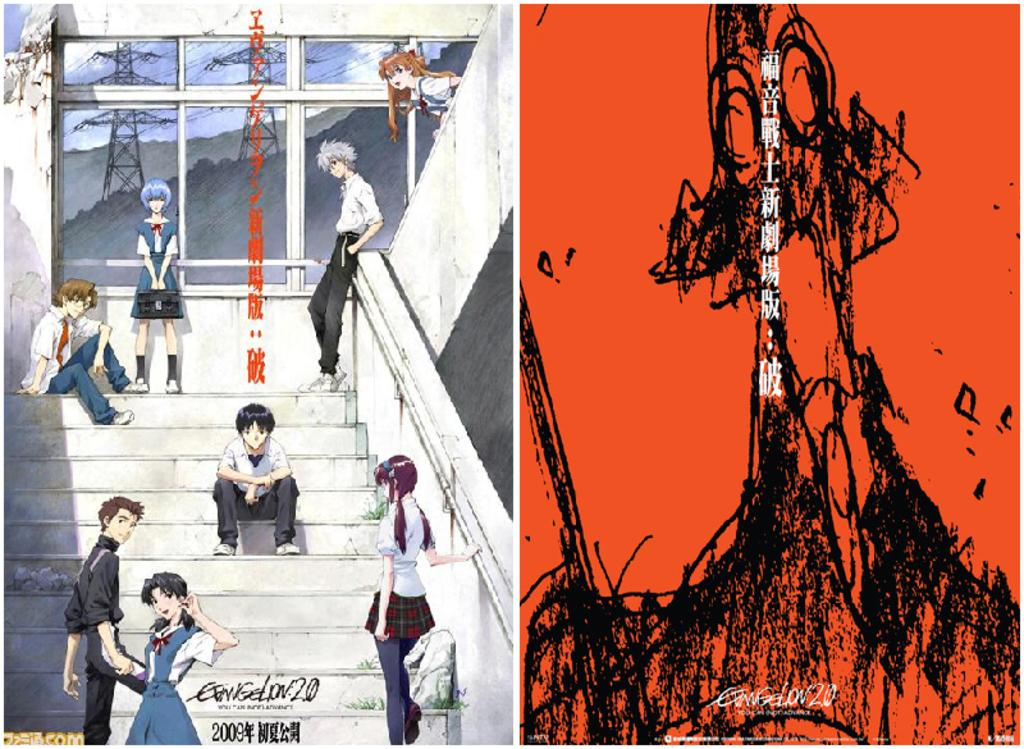<image>
Present a compact description of the photo's key features. Two animie posters, one 2009 showing students sitting inside a building in a staircase and another poster in black scribble on orange background. 